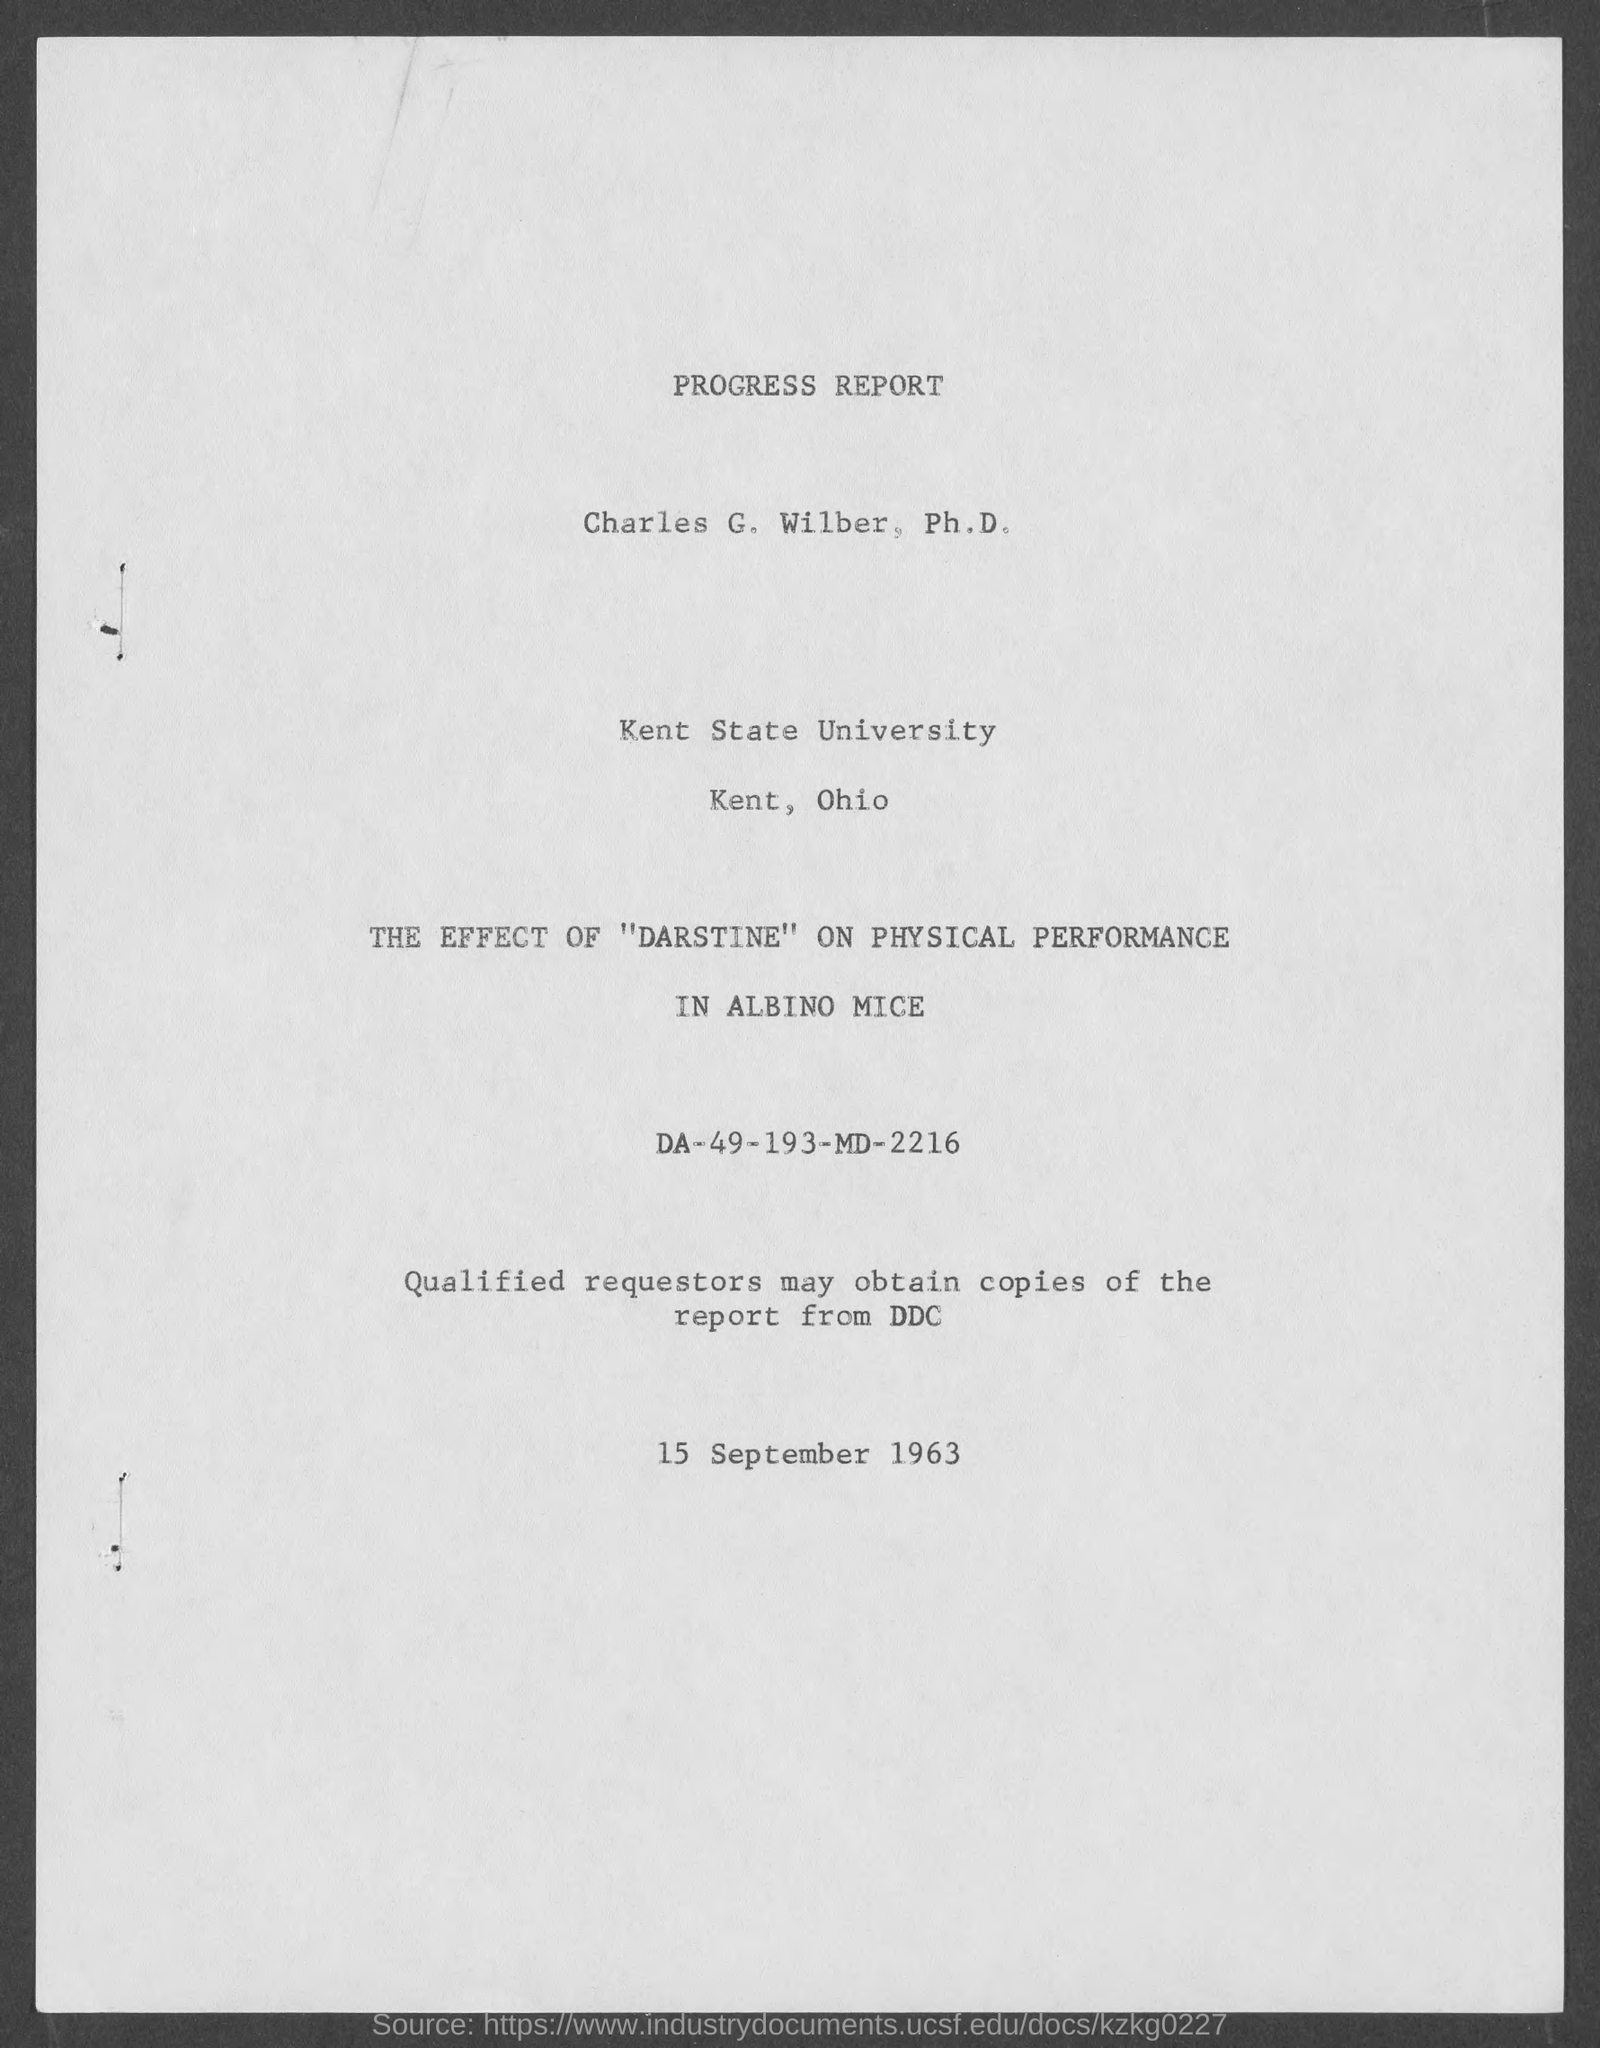Identify some key points in this picture. Kent State University is located in the state of Ohio. The date at the bottom of the page is September 15, 1963. 